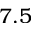<formula> <loc_0><loc_0><loc_500><loc_500>7 . 5</formula> 